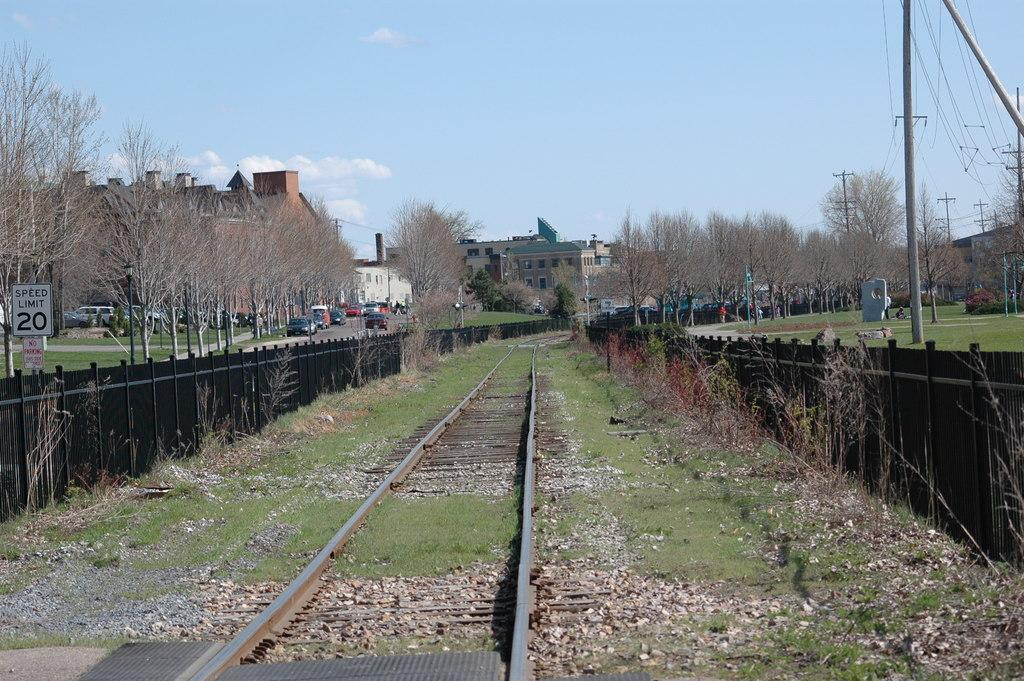What type of transportation infrastructure is present in the image? There is a railway track in the image. What type of barrier can be seen in the image? There is a fence in the image. What type of vegetation is present in the image? There are trees and grass in the image. What type of ground surface is present in the image? There are stones in the image. What type of structures are present in the image? There are buildings in the image. What type of vehicles are present in the image? There are vehicles in the image. What type of utility infrastructure is present in the image? There are electrical poles in the image. What can be seen in the background of the image? The sky is visible in the background of the image. Where are the toys scattered in the image? There are no toys present in the image. What type of dessert is being served in the image? There is no dessert present in the image. What is the person writing in the image? There is no person writing or using a notebook in the image. 